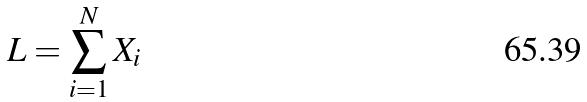<formula> <loc_0><loc_0><loc_500><loc_500>L = \sum _ { i = 1 } ^ { N } X _ { i }</formula> 